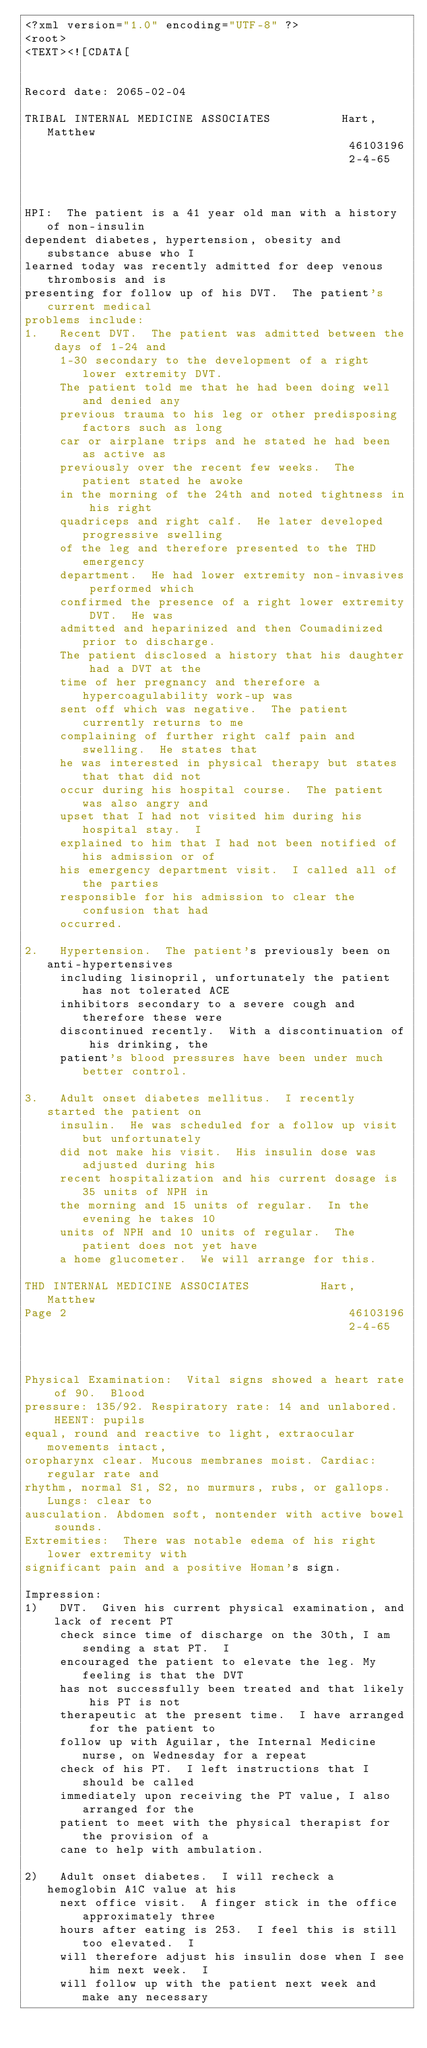Convert code to text. <code><loc_0><loc_0><loc_500><loc_500><_XML_><?xml version="1.0" encoding="UTF-8" ?>
<root>
<TEXT><![CDATA[


Record date: 2065-02-04

TRIBAL INTERNAL MEDICINE ASSOCIATES          Hart, Matthew
                                              46103196
                                              2-4-65
 
 
 
HPI:  The patient is a 41 year old man with a history of non-insulin 
dependent diabetes, hypertension, obesity and substance abuse who I 
learned today was recently admitted for deep venous thrombosis and is 
presenting for follow up of his DVT.  The patient's current medical 
problems include:
1.   Recent DVT.  The patient was admitted between the days of 1-24 and 
     1-30 secondary to the development of a right lower extremity DVT.  
     The patient told me that he had been doing well and denied any 
     previous trauma to his leg or other predisposing factors such as long 
     car or airplane trips and he stated he had been as active as 
     previously over the recent few weeks.  The patient stated he awoke 
     in the morning of the 24th and noted tightness in his right 
     quadriceps and right calf.  He later developed progressive swelling 
     of the leg and therefore presented to the THD emergency 
     department.  He had lower extremity non-invasives performed which 
     confirmed the presence of a right lower extremity DVT.  He was 
     admitted and heparinized and then Coumadinized prior to discharge.  
     The patient disclosed a history that his daughter had a DVT at the 
     time of her pregnancy and therefore a hypercoagulability work-up was 
     sent off which was negative.  The patient currently returns to me 
     complaining of further right calf pain and swelling.  He states that 
     he was interested in physical therapy but states that that did not 
     occur during his hospital course.  The patient was also angry and 
     upset that I had not visited him during his hospital stay.  I 
     explained to him that I had not been notified of his admission or of 
     his emergency department visit.  I called all of the parties 
     responsible for his admission to clear the confusion that had 
     occurred.
 
2.   Hypertension.  The patient's previously been on anti-hypertensives 
     including lisinopril, unfortunately the patient has not tolerated ACE 
     inhibitors secondary to a severe cough and therefore these were 
     discontinued recently.  With a discontinuation of his drinking, the 
     patient's blood pressures have been under much better control.
 
3.   Adult onset diabetes mellitus.  I recently started the patient on 
     insulin.  He was scheduled for a follow up visit but unfortunately 
     did not make his visit.  His insulin dose was adjusted during his 
     recent hospitalization and his current dosage is 35 units of NPH in 
     the morning and 15 units of regular.  In the evening he takes 10 
     units of NPH and 10 units of regular.  The patient does not yet have 
     a home glucometer.  We will arrange for this.
 
THD INTERNAL MEDICINE ASSOCIATES          Hart, Matthew
Page 2                                        46103196
                                              2-4-65
 
 
 
Physical Examination:  Vital signs showed a heart rate of 90.  Blood 
pressure: 135/92. Respiratory rate: 14 and unlabored.  HEENT: pupils 
equal, round and reactive to light, extraocular movements intact, 
oropharynx clear. Mucous membranes moist. Cardiac: regular rate and 
rhythm, normal S1, S2, no murmurs, rubs, or gallops.  Lungs: clear to 
ausculation. Abdomen soft, nontender with active bowel sounds.  
Extremities:  There was notable edema of his right lower extremity with 
significant pain and a positive Homan's sign.  
 
Impression:
1)   DVT.  Given his current physical examination, and lack of recent PT 
     check since time of discharge on the 30th, I am sending a stat PT.  I 
     encouraged the patient to elevate the leg. My feeling is that the DVT 
     has not successfully been treated and that likely his PT is not 
     therapeutic at the present time.  I have arranged for the patient to 
     follow up with Aguilar, the Internal Medicine nurse, on Wednesday for a repeat 
     check of his PT.  I left instructions that I should be called 
     immediately upon receiving the PT value, I also arranged for the 
     patient to meet with the physical therapist for the provision of a 
     cane to help with ambulation. 
 
2)   Adult onset diabetes.  I will recheck a hemoglobin A1C value at his 
     next office visit.  A finger stick in the office approximately three 
     hours after eating is 253.  I feel this is still too elevated.  I 
     will therefore adjust his insulin dose when I see him next week.  I 
     will follow up with the patient next week and make any necessary </code> 